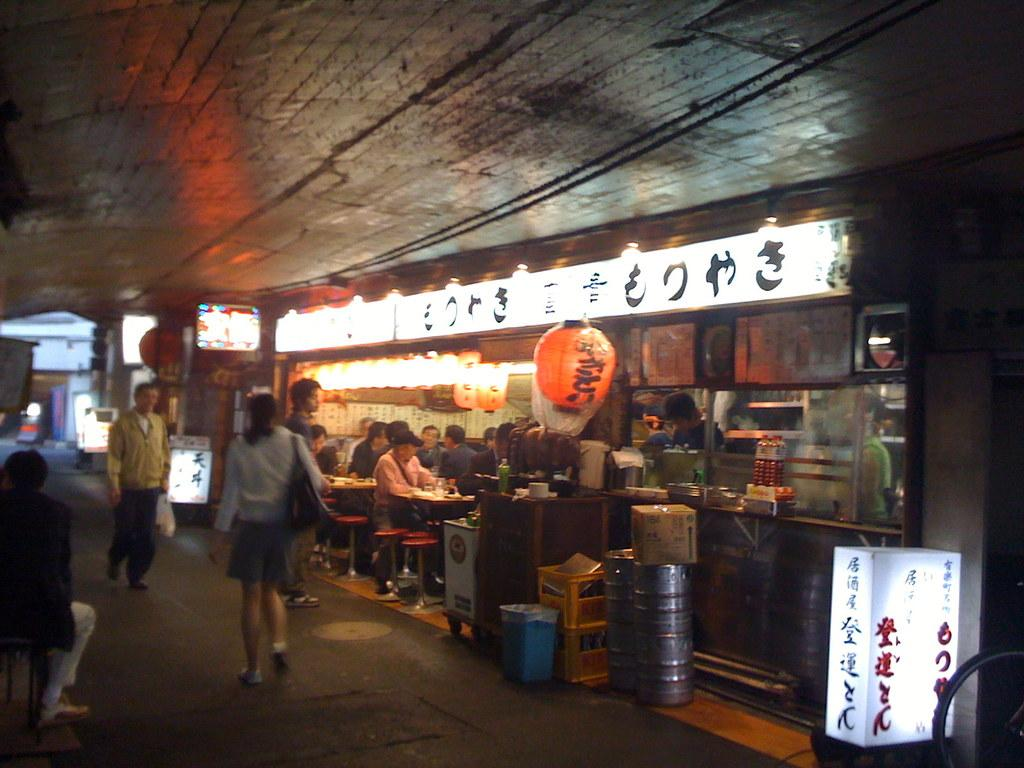What type of establishment is located on the right side of the image? There is a store on the right side of the image. What object can be seen in the image that is typically used for storage or transportation? There is a cardboard box in the image. What object is present in the image for waste disposal? There is a dustbin in the image. What type of container is visible in the image that is often used for storing liquids? There are barrels in the image. What are the people in the image doing? There are people sitting on chairs in the image. What type of signage is present in the image? There is a hoarding in the image. Can you describe the zephyr that is blowing the balls in the image? There is no zephyr or balls present in the image. What type of flight is taking place in the image? There is no flight or any indication of air travel in the image. 